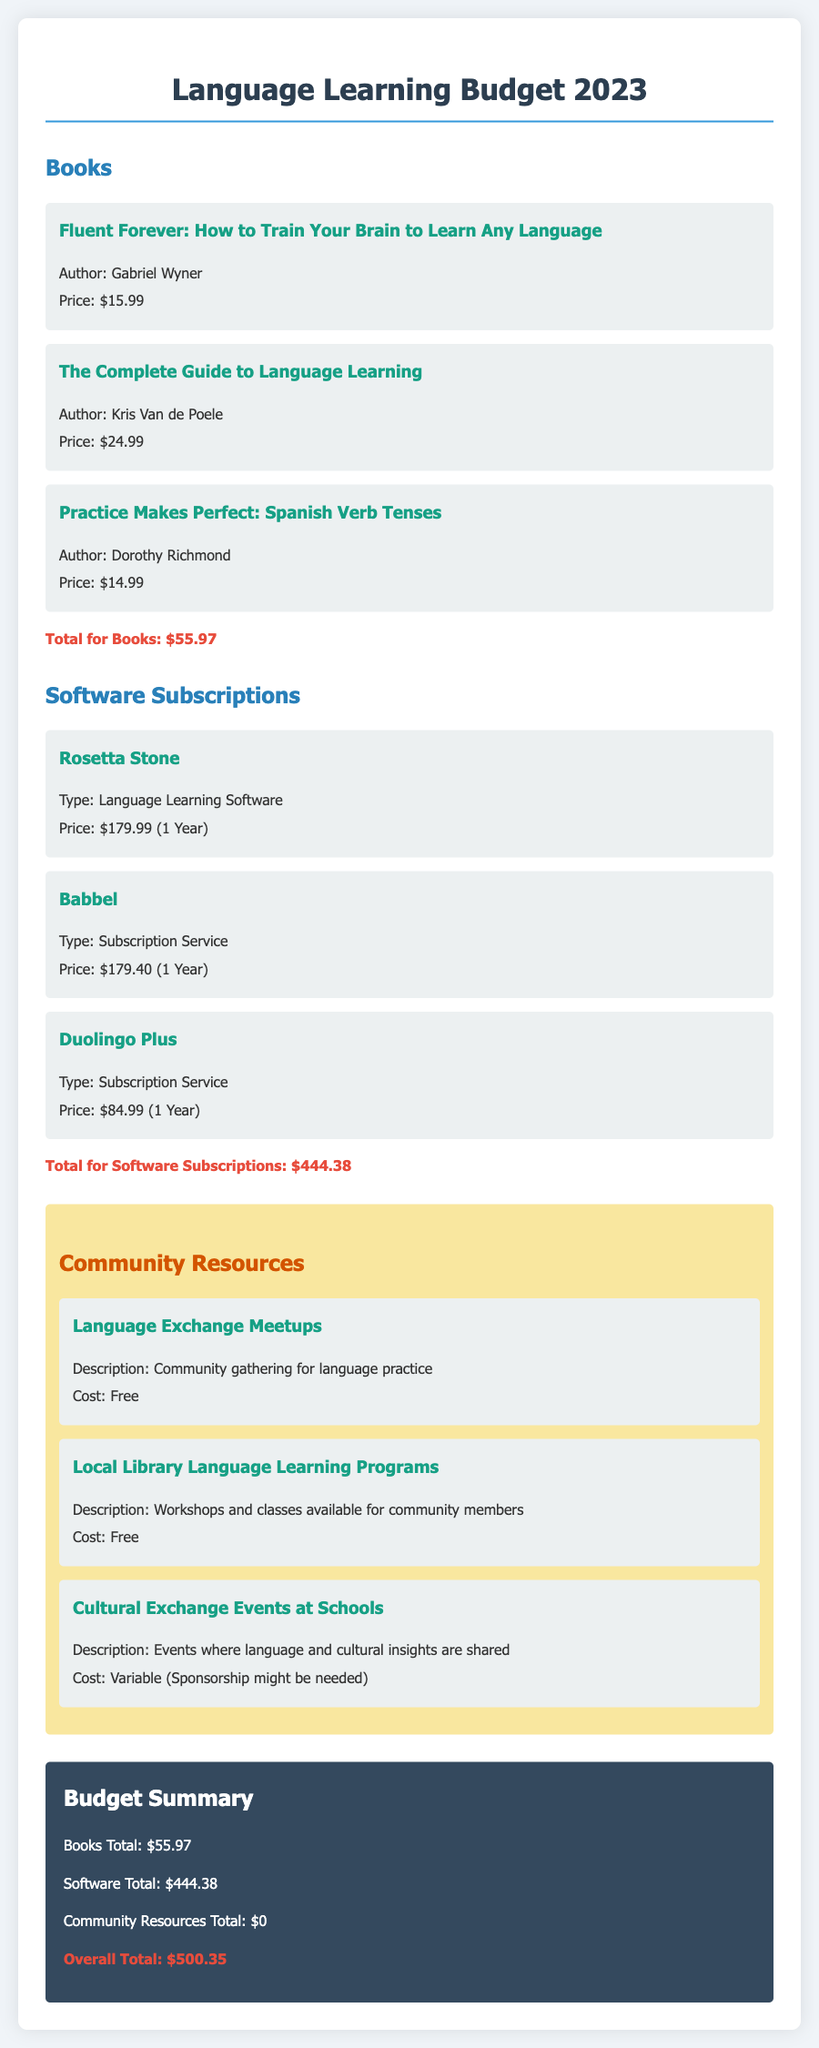What is the price of "Fluent Forever"? The price of "Fluent Forever: How to Train Your Brain to Learn Any Language" is listed in the document.
Answer: $15.99 What is the total cost for books? The total cost for books is calculated by summing the prices of all listed books in the document.
Answer: $55.97 How much does Rosetta Stone cost? The cost of Rosetta Stone is stated in the software subscriptions section of the document.
Answer: $179.99 What is the total for software subscriptions? The total for software subscriptions is the sum of all software prices mentioned in the document.
Answer: $444.38 Are the Language Exchange Meetups free? The cost of the Language Exchange Meetups is explicitly mentioned in the document.
Answer: Free What type of resources does the budget cover? The budget covers three types of resources related to language learning as outlined in the document.
Answer: Books, Software Subscriptions, Community Resources What is the overall total budget amount? The overall total budget amount is the sum of the total expenses outlined in the document.
Answer: $500.35 How many books are listed in the document? The document contains a specific section with a number of books that can be counted.
Answer: Three What is the description of "Cultural Exchange Events at Schools"? The description is provided in the community resources section of the document.
Answer: Events where language and cultural insights are shared 